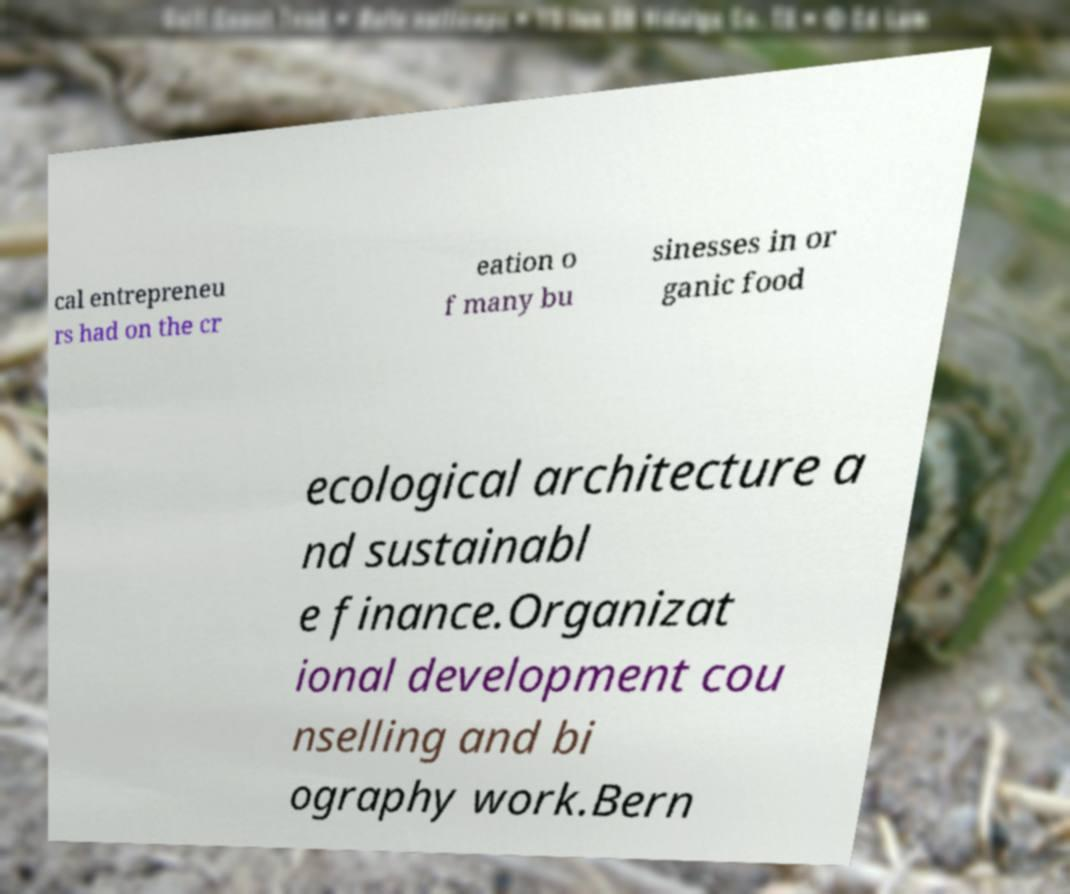What messages or text are displayed in this image? I need them in a readable, typed format. cal entrepreneu rs had on the cr eation o f many bu sinesses in or ganic food ecological architecture a nd sustainabl e finance.Organizat ional development cou nselling and bi ography work.Bern 